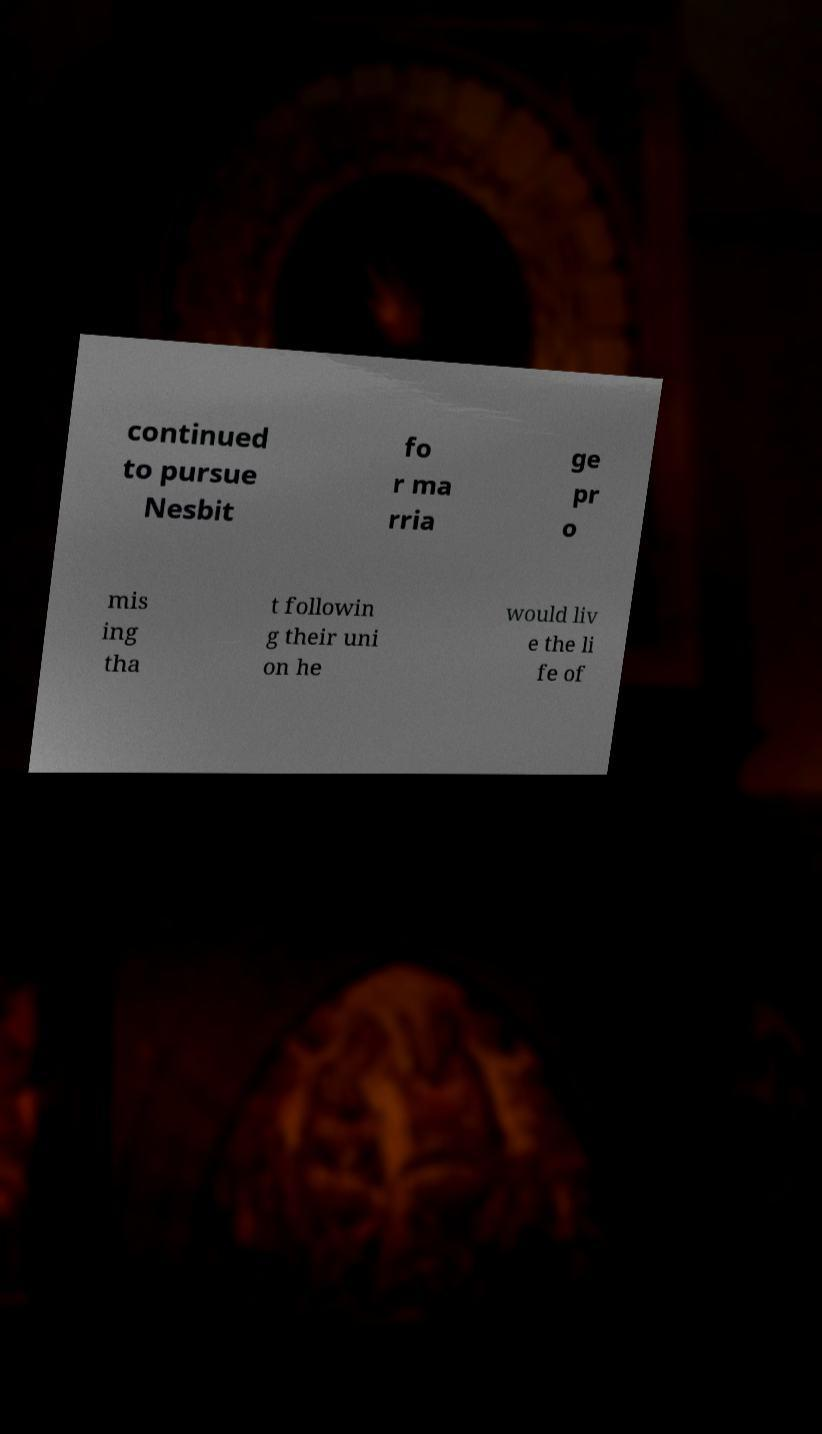I need the written content from this picture converted into text. Can you do that? continued to pursue Nesbit fo r ma rria ge pr o mis ing tha t followin g their uni on he would liv e the li fe of 